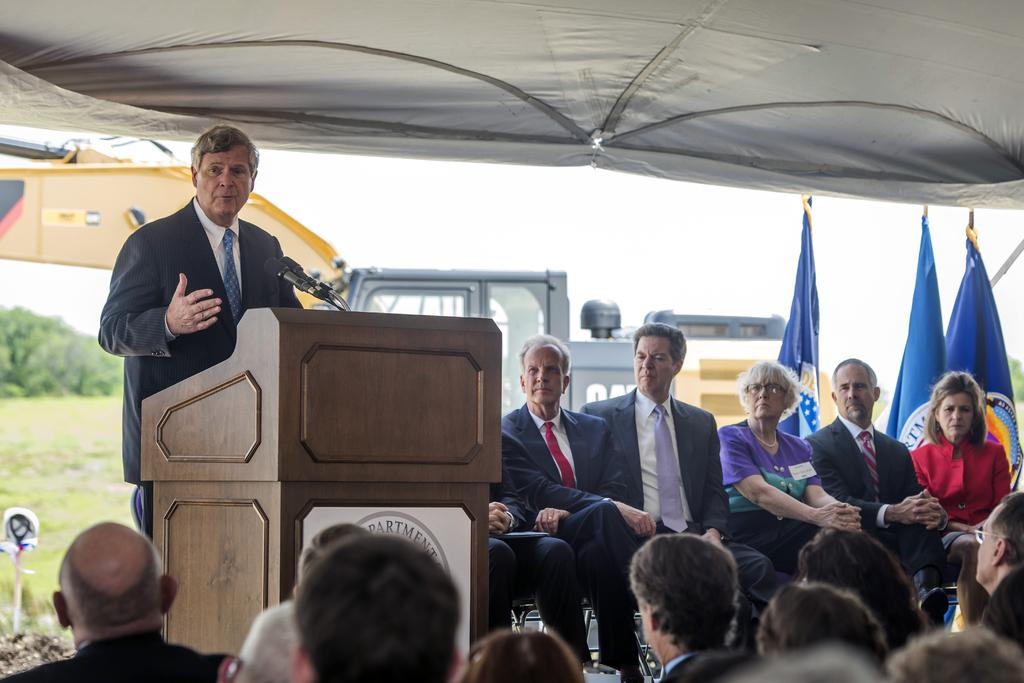What is the man in the image doing? The man is talking on a microphone. What object is present in front of the man? There is a podium in the image. What are the people in the image doing? There is a group of people sitting on chairs. What can be seen in the background of the image? There are flags, trees, and the sky visible in the background of the image. What type of steel is used to construct the clouds in the image? There are no clouds made of steel in the image; the clouds are natural formations in the sky. 